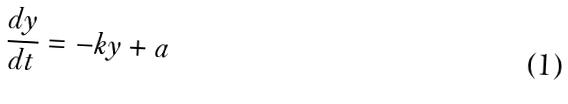Convert formula to latex. <formula><loc_0><loc_0><loc_500><loc_500>\frac { d y } { d t } = - k y + a</formula> 